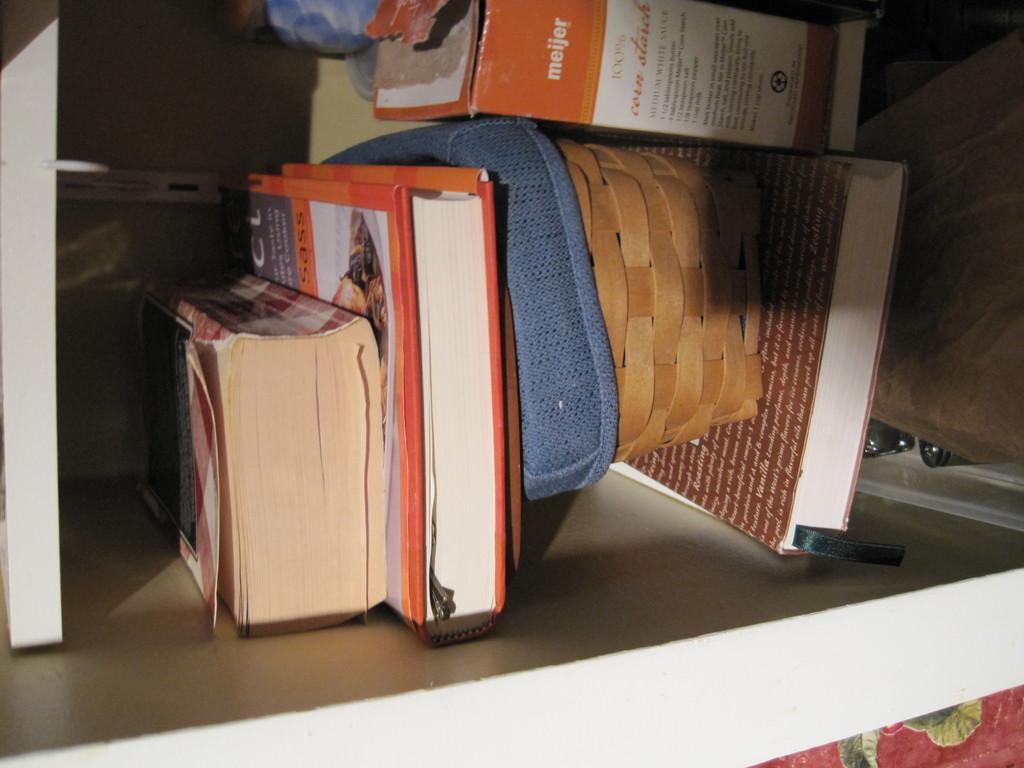What can be seen on the shelf in the image? There are books, a basket, and a box on the shelf. Are there any other items on the shelf besides books, a basket, and a box? Yes, there are other things on the shelf. Can you describe the basket on the shelf? The basket is an object on the shelf, but its specific characteristics are not mentioned in the facts. What is the purpose of the box on the shelf? The purpose of the box on the shelf is not mentioned in the facts. What type of operation is being performed on the shelf in the image? There is no operation being performed on the shelf in the image. What is the range of the shelf in the image? The range of the shelf is not mentioned in the facts, and it is not a physical characteristic that can be determined from the image. 